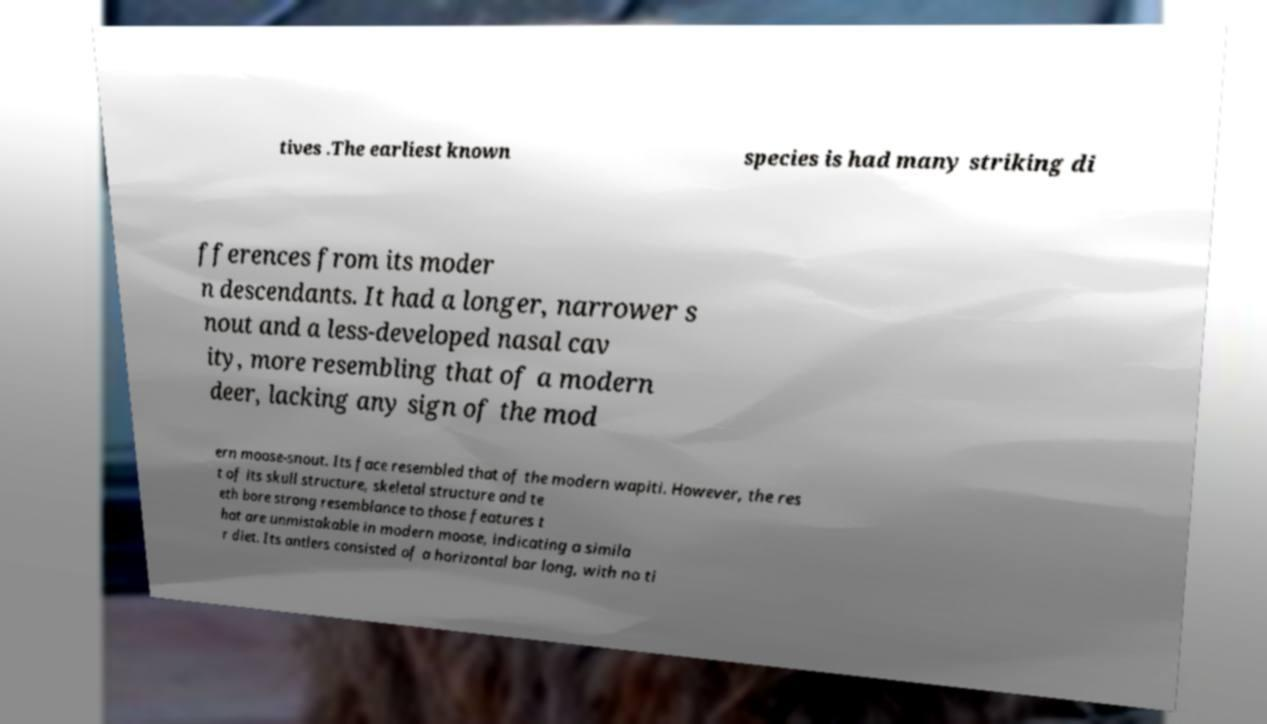Can you read and provide the text displayed in the image?This photo seems to have some interesting text. Can you extract and type it out for me? tives .The earliest known species is had many striking di fferences from its moder n descendants. It had a longer, narrower s nout and a less-developed nasal cav ity, more resembling that of a modern deer, lacking any sign of the mod ern moose-snout. Its face resembled that of the modern wapiti. However, the res t of its skull structure, skeletal structure and te eth bore strong resemblance to those features t hat are unmistakable in modern moose, indicating a simila r diet. Its antlers consisted of a horizontal bar long, with no ti 